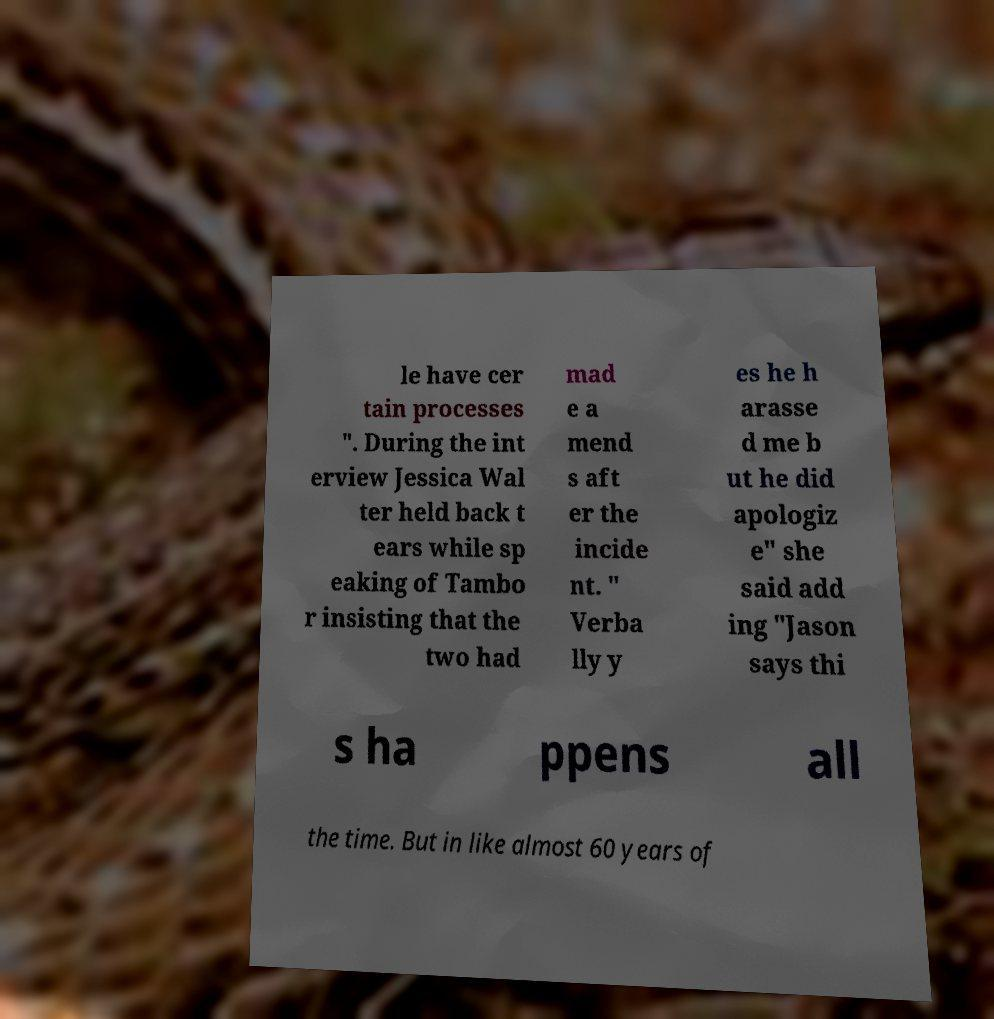Please read and relay the text visible in this image. What does it say? le have cer tain processes ". During the int erview Jessica Wal ter held back t ears while sp eaking of Tambo r insisting that the two had mad e a mend s aft er the incide nt. " Verba lly y es he h arasse d me b ut he did apologiz e" she said add ing "Jason says thi s ha ppens all the time. But in like almost 60 years of 